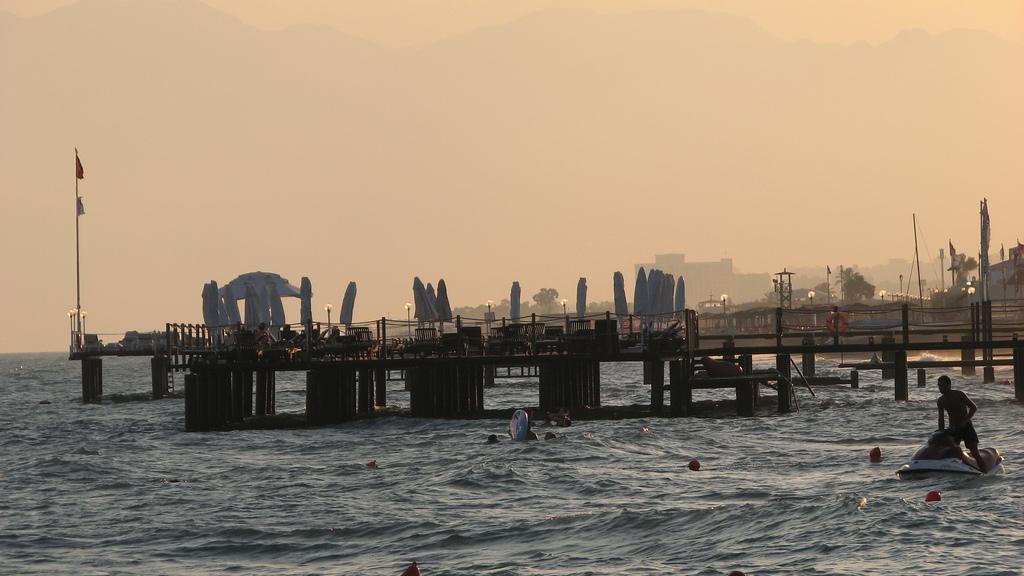How would you summarize this image in a sentence or two? In the center of the image we can see a wooden pier, water, one person on the boat and a few people are in the water. In the background, we can see the sky, buildings, trees, poles and a few other objects. 